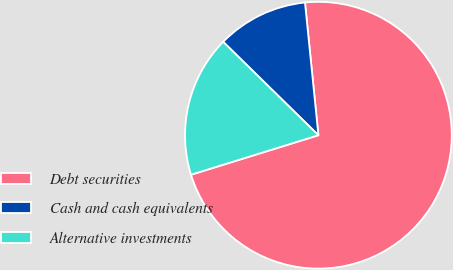Convert chart. <chart><loc_0><loc_0><loc_500><loc_500><pie_chart><fcel>Debt securities<fcel>Cash and cash equivalents<fcel>Alternative investments<nl><fcel>71.82%<fcel>11.05%<fcel>17.13%<nl></chart> 